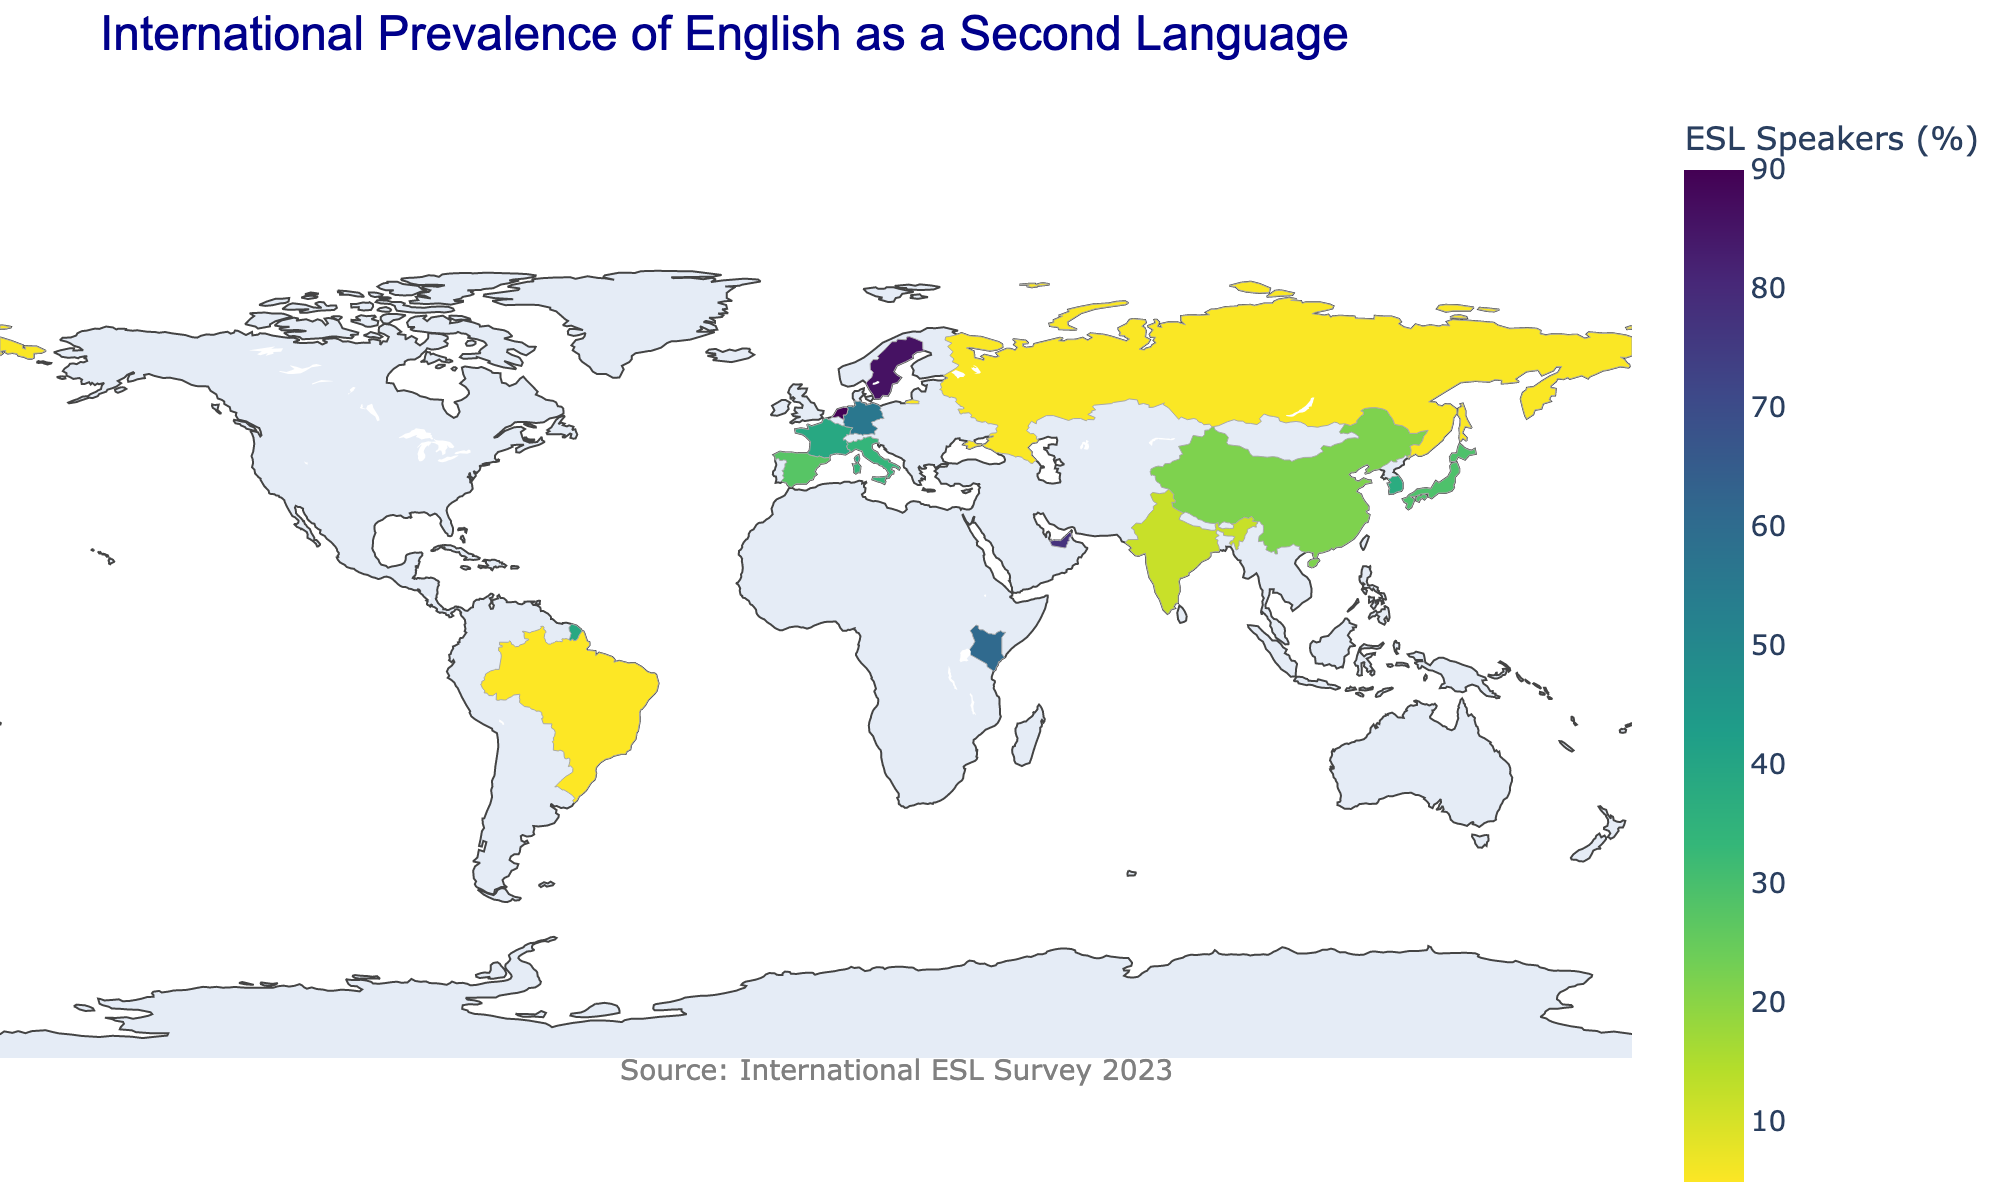How many countries are analyzed in the figure? Count the number of unique countries listed in the data.
Answer: 15 Which country has the highest percentage of English as a Second Language (ESL) speakers? Look for the country with the highest Total_ESL_Speakers(%).
Answer: Netherlands What is the difference in total ESL speaker percentages between Germany and South Korea? Subtract Germany's Total_ESL_Speakers(%) from South Korea's Total_ESL_Speakers(%): 56.1% - 37.5%.
Answer: 18.6 Among China, India, and Japan, which country has the least percentage of advanced proficiency speakers? Identify the advanced proficiency percentages for China, India, and Japan, then find the smallest: 2.2% (China), 2.2% (India), 3.3% (Japan).
Answer: China and India What percentage of ESL speakers in the UAE have basic proficiency? Identify the Basic Proficiency percentage for the UAE from the figure.
Answer: 22.3% Which country has the highest percentage of intermediate proficiency ESL speakers? Look for the country with the highest Intermediate_Proficiency(%).
Answer: Netherlands What is the average percentage of advanced proficiency ESL speakers in France and Italy? Calculate the average of France's and Italy's Advanced Proficiency(%): (6.3% + 4.3%) / 2.
Answer: 5.3% Which countries have more than 50% of their ESL speakers with at least intermediate proficiency? Identify countries where Intermediate_Proficiency(%) + Advanced_Proficiency(%) > 50%.
Answer: Netherlands, Sweden, Singapore, and UAE Compare the total ESL speaker percentages of Brazil and Russia and determine who has more. Compare the Total_ESL_Speakers(%): Brazil (5.1%) and Russia (5.5%).
Answer: Russia What is the distribution of total ESL speaker percentages across Europe? Identify the Total_ESL_Speakers(%) for Germany, France, Italy, Spain, Sweden, and the Netherlands.
Answer: Germany (56.1%), France (39%), Italy (34%), Spain (27.7%), Sweden (86%), Netherlands (90%) 